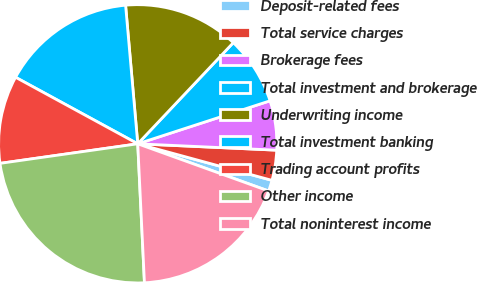<chart> <loc_0><loc_0><loc_500><loc_500><pie_chart><fcel>Deposit-related fees<fcel>Total service charges<fcel>Brokerage fees<fcel>Total investment and brokerage<fcel>Underwriting income<fcel>Total investment banking<fcel>Trading account profits<fcel>Other income<fcel>Total noninterest income<nl><fcel>1.28%<fcel>3.5%<fcel>5.73%<fcel>7.95%<fcel>13.44%<fcel>15.67%<fcel>10.18%<fcel>23.52%<fcel>18.72%<nl></chart> 